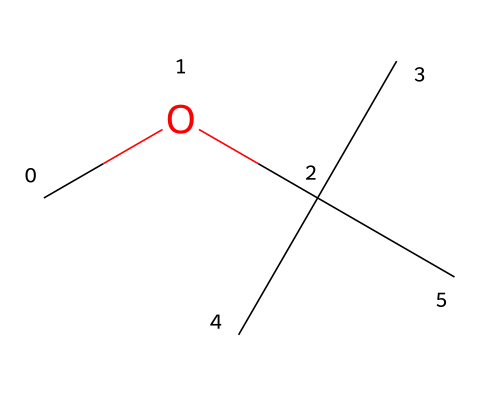What is the molecular formula of methyl tert-butyl ether? To find the molecular formula, count the number of each type of atom in the structure as represented by the SMILES. There are 5 carbon atoms and 12 hydrogen atoms, along with 1 oxygen atom, giving us a formula of C5H12O.
Answer: C5H12O How many carbon atoms are present in this compound? Examining the SMILES representation, we can see that there are 5 carbon atoms in total, based on the branching and the main carbon chain.
Answer: 5 What type of functional group does methyl tert-butyl ether belong to? The SMILES structure shows an ether linkage (C-O-C), which indicates that this compound is classified as an ether.
Answer: ether What is the total number of hydrogen atoms in the structure? By adding the hydrogen atoms associated with each carbon, there are 12 hydrogen atoms in total represented in the structure.
Answer: 12 Why is methyl tert-butyl ether commonly used as a gasoline additive? The structure includes a branched alkyl group (tert-butyl) which helps improve the octane rating and reduce engine knocking, making it effective as a gasoline additive.
Answer: improve octane rating What is one of the environmental concerns associated with methyl tert-butyl ether? Due to its solubility and persistence, MTBE can contaminate groundwater, which is a major environmental concern.
Answer: groundwater contamination 